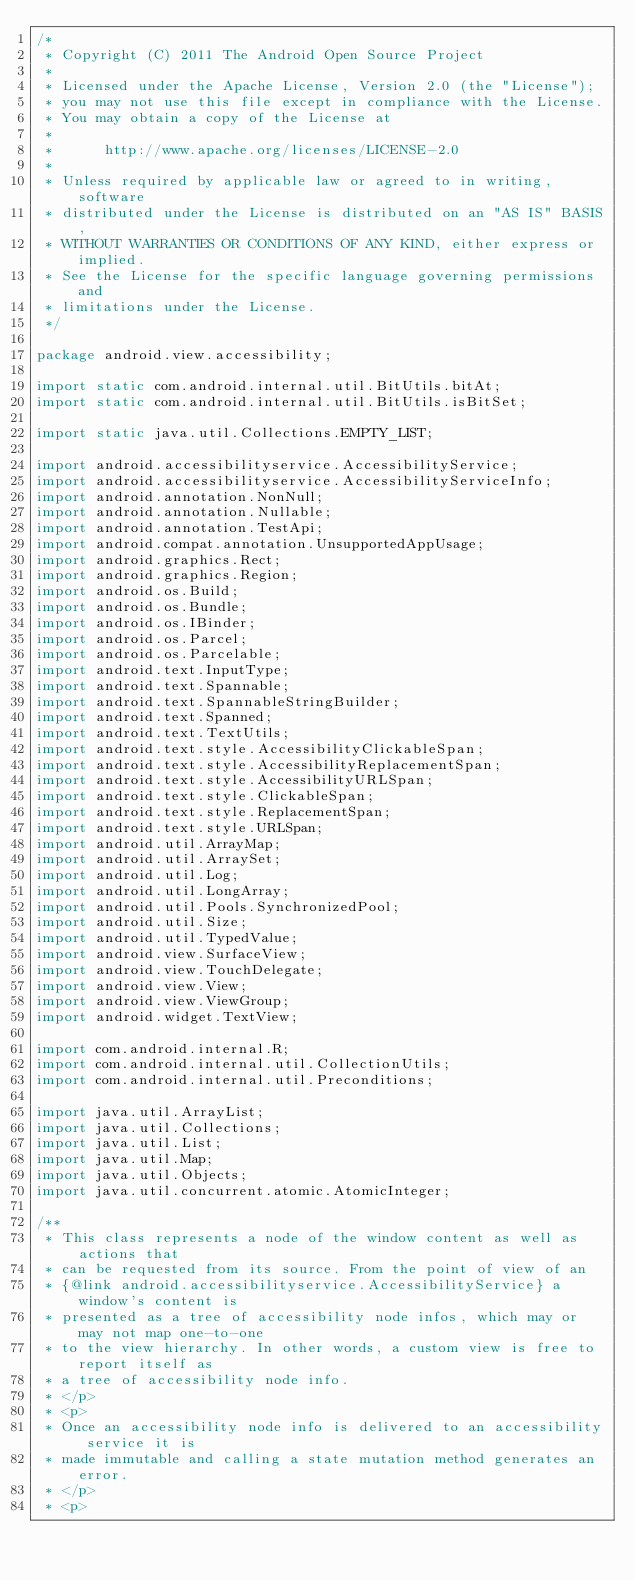<code> <loc_0><loc_0><loc_500><loc_500><_Java_>/*
 * Copyright (C) 2011 The Android Open Source Project
 *
 * Licensed under the Apache License, Version 2.0 (the "License");
 * you may not use this file except in compliance with the License.
 * You may obtain a copy of the License at
 *
 *      http://www.apache.org/licenses/LICENSE-2.0
 *
 * Unless required by applicable law or agreed to in writing, software
 * distributed under the License is distributed on an "AS IS" BASIS,
 * WITHOUT WARRANTIES OR CONDITIONS OF ANY KIND, either express or implied.
 * See the License for the specific language governing permissions and
 * limitations under the License.
 */

package android.view.accessibility;

import static com.android.internal.util.BitUtils.bitAt;
import static com.android.internal.util.BitUtils.isBitSet;

import static java.util.Collections.EMPTY_LIST;

import android.accessibilityservice.AccessibilityService;
import android.accessibilityservice.AccessibilityServiceInfo;
import android.annotation.NonNull;
import android.annotation.Nullable;
import android.annotation.TestApi;
import android.compat.annotation.UnsupportedAppUsage;
import android.graphics.Rect;
import android.graphics.Region;
import android.os.Build;
import android.os.Bundle;
import android.os.IBinder;
import android.os.Parcel;
import android.os.Parcelable;
import android.text.InputType;
import android.text.Spannable;
import android.text.SpannableStringBuilder;
import android.text.Spanned;
import android.text.TextUtils;
import android.text.style.AccessibilityClickableSpan;
import android.text.style.AccessibilityReplacementSpan;
import android.text.style.AccessibilityURLSpan;
import android.text.style.ClickableSpan;
import android.text.style.ReplacementSpan;
import android.text.style.URLSpan;
import android.util.ArrayMap;
import android.util.ArraySet;
import android.util.Log;
import android.util.LongArray;
import android.util.Pools.SynchronizedPool;
import android.util.Size;
import android.util.TypedValue;
import android.view.SurfaceView;
import android.view.TouchDelegate;
import android.view.View;
import android.view.ViewGroup;
import android.widget.TextView;

import com.android.internal.R;
import com.android.internal.util.CollectionUtils;
import com.android.internal.util.Preconditions;

import java.util.ArrayList;
import java.util.Collections;
import java.util.List;
import java.util.Map;
import java.util.Objects;
import java.util.concurrent.atomic.AtomicInteger;

/**
 * This class represents a node of the window content as well as actions that
 * can be requested from its source. From the point of view of an
 * {@link android.accessibilityservice.AccessibilityService} a window's content is
 * presented as a tree of accessibility node infos, which may or may not map one-to-one
 * to the view hierarchy. In other words, a custom view is free to report itself as
 * a tree of accessibility node info.
 * </p>
 * <p>
 * Once an accessibility node info is delivered to an accessibility service it is
 * made immutable and calling a state mutation method generates an error.
 * </p>
 * <p></code> 